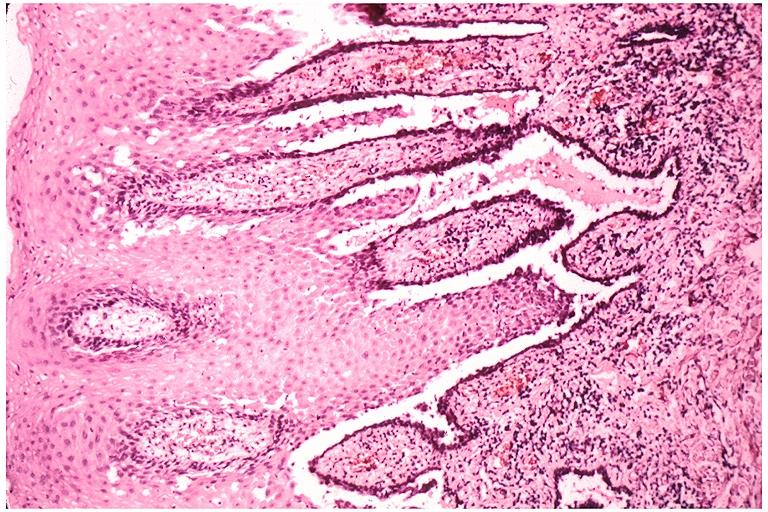what does this image show?
Answer the question using a single word or phrase. Pemphigus vulgaris 